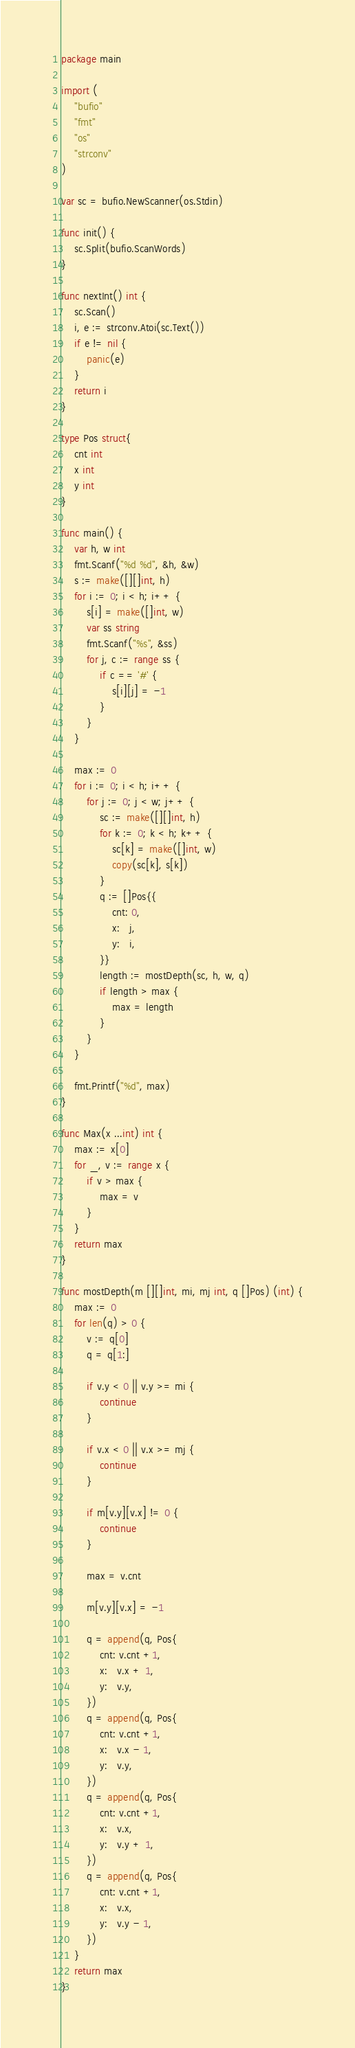<code> <loc_0><loc_0><loc_500><loc_500><_Go_>package main

import (
	"bufio"
	"fmt"
	"os"
	"strconv"
)

var sc = bufio.NewScanner(os.Stdin)

func init() {
	sc.Split(bufio.ScanWords)
}

func nextInt() int {
	sc.Scan()
	i, e := strconv.Atoi(sc.Text())
	if e != nil {
		panic(e)
	}
	return i
}

type Pos struct{
	cnt int
	x int
	y int
}

func main() {
	var h, w int
	fmt.Scanf("%d %d", &h, &w)
	s := make([][]int, h)
	for i := 0; i < h; i++ {
		s[i] = make([]int, w)
		var ss string
		fmt.Scanf("%s", &ss)
		for j, c := range ss {
			if c == '#' {
				s[i][j] = -1
			}
		}
	}

	max := 0
	for i := 0; i < h; i++ {
		for j := 0; j < w; j++ {
			sc := make([][]int, h)
			for k := 0; k < h; k++ {
				sc[k] = make([]int, w)
				copy(sc[k], s[k])
			}
			q := []Pos{{
				cnt: 0,
				x:   j,
				y:   i,
			}}
			length := mostDepth(sc, h, w, q)
			if length > max {
				max = length
			}
		}
	}

	fmt.Printf("%d", max)
}

func Max(x ...int) int {
	max := x[0]
	for _, v := range x {
		if v > max {
			max = v
		}
	}
	return max
}

func mostDepth(m [][]int, mi, mj int, q []Pos) (int) {
	max := 0
	for len(q) > 0 {
		v := q[0]
		q = q[1:]

		if v.y < 0 || v.y >= mi {
			continue
		}

		if v.x < 0 || v.x >= mj {
			continue
		}

		if m[v.y][v.x] != 0 {
			continue
		}

		max = v.cnt

		m[v.y][v.x] = -1

		q = append(q, Pos{
			cnt: v.cnt +1,
			x:   v.x + 1,
			y:   v.y,
		})
		q = append(q, Pos{
			cnt: v.cnt +1,
			x:   v.x - 1,
			y:   v.y,
		})
		q = append(q, Pos{
			cnt: v.cnt +1,
			x:   v.x,
			y:   v.y + 1,
		})
		q = append(q, Pos{
			cnt: v.cnt +1,
			x:   v.x,
			y:   v.y - 1,
		})
	}
	return max
}
</code> 